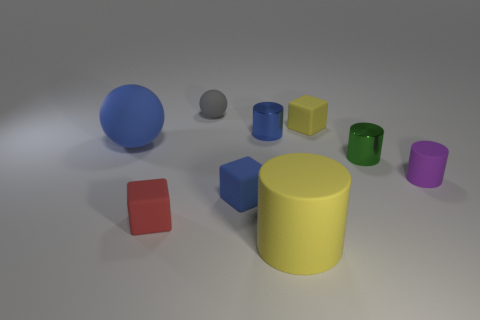What number of small objects are either gray matte things or red cubes?
Your answer should be compact. 2. There is a big object left of the small blue rubber thing; is it the same color as the tiny metal cylinder behind the green metal cylinder?
Give a very brief answer. Yes. How many other objects are there of the same color as the small sphere?
Keep it short and to the point. 0. What number of green things are big rubber spheres or spheres?
Make the answer very short. 0. There is a purple thing; is it the same shape as the metallic thing that is behind the blue ball?
Offer a terse response. Yes. What is the shape of the small blue metallic thing?
Make the answer very short. Cylinder. What is the material of the blue cylinder that is the same size as the purple cylinder?
Offer a terse response. Metal. How many objects are large purple spheres or small cylinders behind the large blue object?
Ensure brevity in your answer.  1. There is a blue sphere that is the same material as the yellow cylinder; what size is it?
Provide a succinct answer. Large. There is a tiny shiny thing left of the yellow thing that is on the left side of the tiny yellow matte object; what is its shape?
Offer a terse response. Cylinder. 